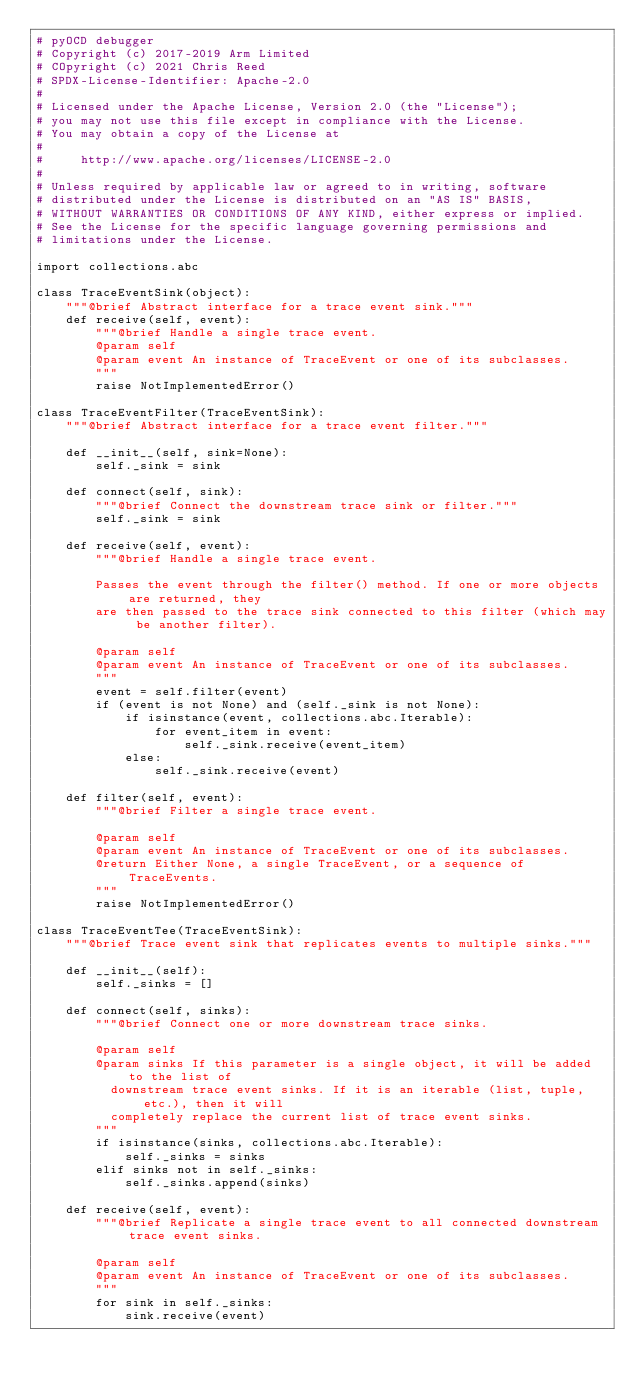<code> <loc_0><loc_0><loc_500><loc_500><_Python_># pyOCD debugger
# Copyright (c) 2017-2019 Arm Limited
# COpyright (c) 2021 Chris Reed
# SPDX-License-Identifier: Apache-2.0
#
# Licensed under the Apache License, Version 2.0 (the "License");
# you may not use this file except in compliance with the License.
# You may obtain a copy of the License at
#
#     http://www.apache.org/licenses/LICENSE-2.0
#
# Unless required by applicable law or agreed to in writing, software
# distributed under the License is distributed on an "AS IS" BASIS,
# WITHOUT WARRANTIES OR CONDITIONS OF ANY KIND, either express or implied.
# See the License for the specific language governing permissions and
# limitations under the License.

import collections.abc

class TraceEventSink(object):
    """@brief Abstract interface for a trace event sink."""
    def receive(self, event):
        """@brief Handle a single trace event.
        @param self
        @param event An instance of TraceEvent or one of its subclasses.
        """
        raise NotImplementedError()

class TraceEventFilter(TraceEventSink):
    """@brief Abstract interface for a trace event filter."""

    def __init__(self, sink=None):
        self._sink = sink

    def connect(self, sink):
        """@brief Connect the downstream trace sink or filter."""
        self._sink = sink

    def receive(self, event):
        """@brief Handle a single trace event.

        Passes the event through the filter() method. If one or more objects are returned, they
        are then passed to the trace sink connected to this filter (which may be another filter).

        @param self
        @param event An instance of TraceEvent or one of its subclasses.
        """
        event = self.filter(event)
        if (event is not None) and (self._sink is not None):
            if isinstance(event, collections.abc.Iterable):
                for event_item in event:
                    self._sink.receive(event_item)
            else:
                self._sink.receive(event)

    def filter(self, event):
        """@brief Filter a single trace event.

        @param self
        @param event An instance of TraceEvent or one of its subclasses.
        @return Either None, a single TraceEvent, or a sequence of TraceEvents.
        """
        raise NotImplementedError()

class TraceEventTee(TraceEventSink):
    """@brief Trace event sink that replicates events to multiple sinks."""

    def __init__(self):
        self._sinks = []

    def connect(self, sinks):
        """@brief Connect one or more downstream trace sinks.

        @param self
        @param sinks If this parameter is a single object, it will be added to the list of
          downstream trace event sinks. If it is an iterable (list, tuple, etc.), then it will
          completely replace the current list of trace event sinks.
        """
        if isinstance(sinks, collections.abc.Iterable):
            self._sinks = sinks
        elif sinks not in self._sinks:
            self._sinks.append(sinks)

    def receive(self, event):
        """@brief Replicate a single trace event to all connected downstream trace event sinks.

        @param self
        @param event An instance of TraceEvent or one of its subclasses.
        """
        for sink in self._sinks:
            sink.receive(event)

</code> 